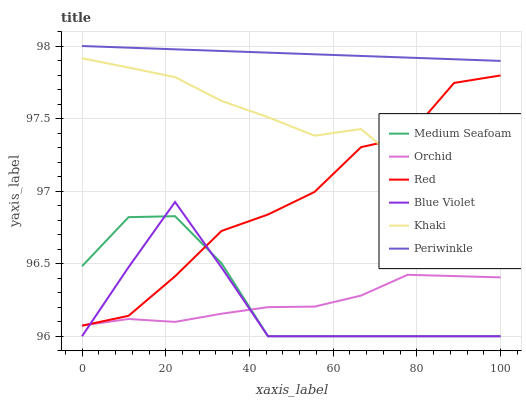Does Blue Violet have the minimum area under the curve?
Answer yes or no. Yes. Does Periwinkle have the maximum area under the curve?
Answer yes or no. Yes. Does Red have the minimum area under the curve?
Answer yes or no. No. Does Red have the maximum area under the curve?
Answer yes or no. No. Is Periwinkle the smoothest?
Answer yes or no. Yes. Is Red the roughest?
Answer yes or no. Yes. Is Red the smoothest?
Answer yes or no. No. Is Periwinkle the roughest?
Answer yes or no. No. Does Red have the lowest value?
Answer yes or no. No. Does Red have the highest value?
Answer yes or no. No. Is Orchid less than Periwinkle?
Answer yes or no. Yes. Is Periwinkle greater than Red?
Answer yes or no. Yes. Does Orchid intersect Periwinkle?
Answer yes or no. No. 